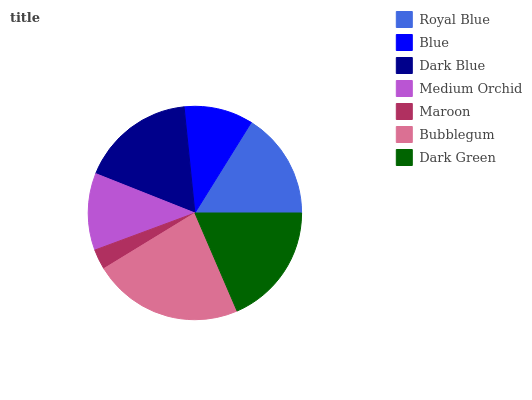Is Maroon the minimum?
Answer yes or no. Yes. Is Bubblegum the maximum?
Answer yes or no. Yes. Is Blue the minimum?
Answer yes or no. No. Is Blue the maximum?
Answer yes or no. No. Is Royal Blue greater than Blue?
Answer yes or no. Yes. Is Blue less than Royal Blue?
Answer yes or no. Yes. Is Blue greater than Royal Blue?
Answer yes or no. No. Is Royal Blue less than Blue?
Answer yes or no. No. Is Royal Blue the high median?
Answer yes or no. Yes. Is Royal Blue the low median?
Answer yes or no. Yes. Is Dark Blue the high median?
Answer yes or no. No. Is Blue the low median?
Answer yes or no. No. 